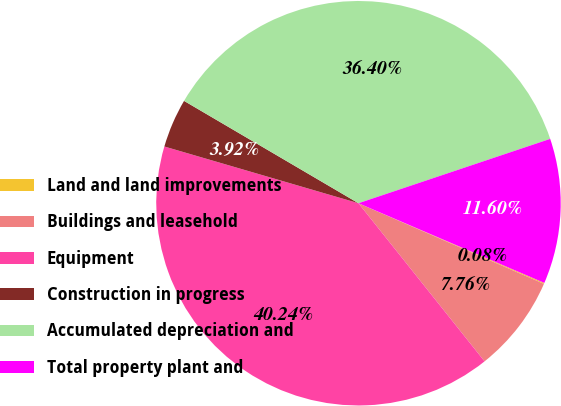Convert chart to OTSL. <chart><loc_0><loc_0><loc_500><loc_500><pie_chart><fcel>Land and land improvements<fcel>Buildings and leasehold<fcel>Equipment<fcel>Construction in progress<fcel>Accumulated depreciation and<fcel>Total property plant and<nl><fcel>0.08%<fcel>7.76%<fcel>40.24%<fcel>3.92%<fcel>36.4%<fcel>11.6%<nl></chart> 